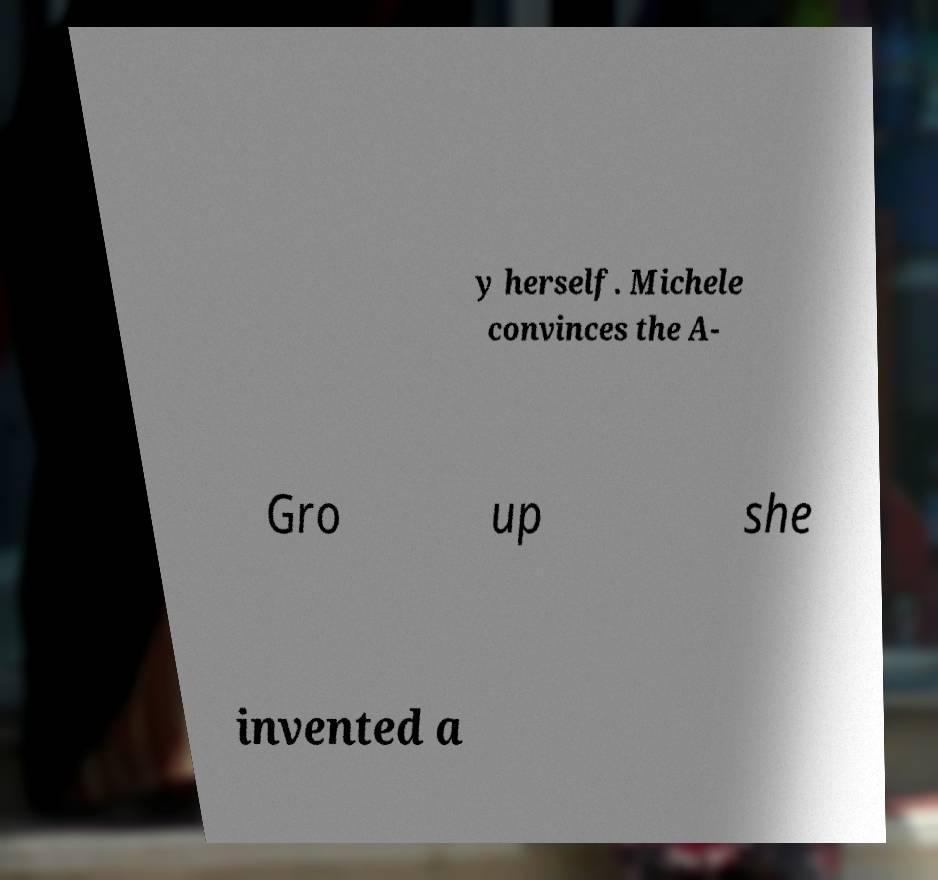Can you accurately transcribe the text from the provided image for me? y herself. Michele convinces the A- Gro up she invented a 